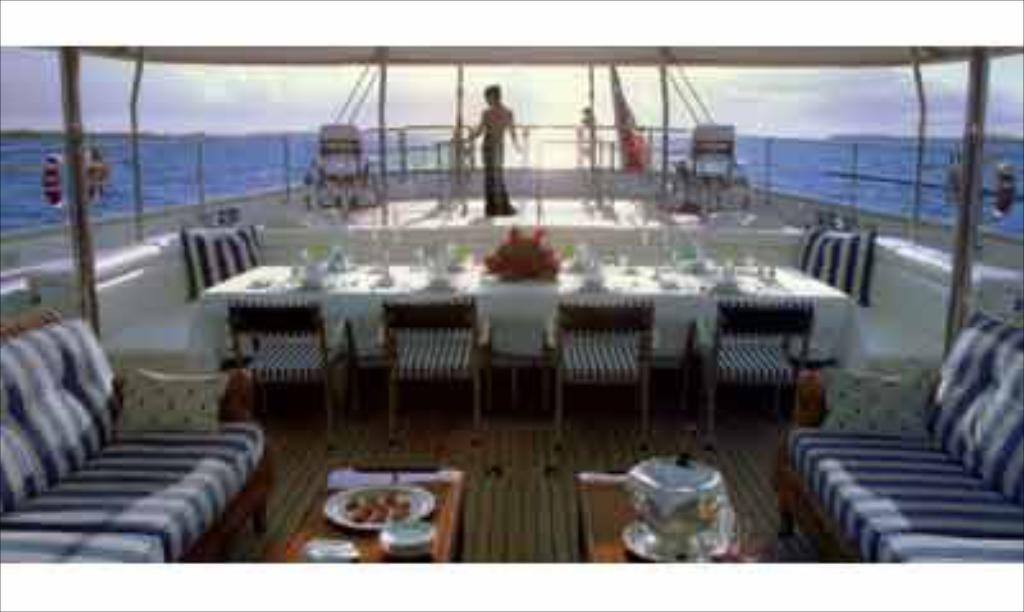What is the main subject of the image? There is a person standing in the image. What objects are on the table in the image? There are glasses on a table in the image. What type of furniture is in front of the person? There are two couches in front of the person. What can be seen in the background of the image? The background of the image includes water in blue color and the sky, which is white in color. What shape is the cloth covering the cart in the image? There is no cloth or cart present in the image. 